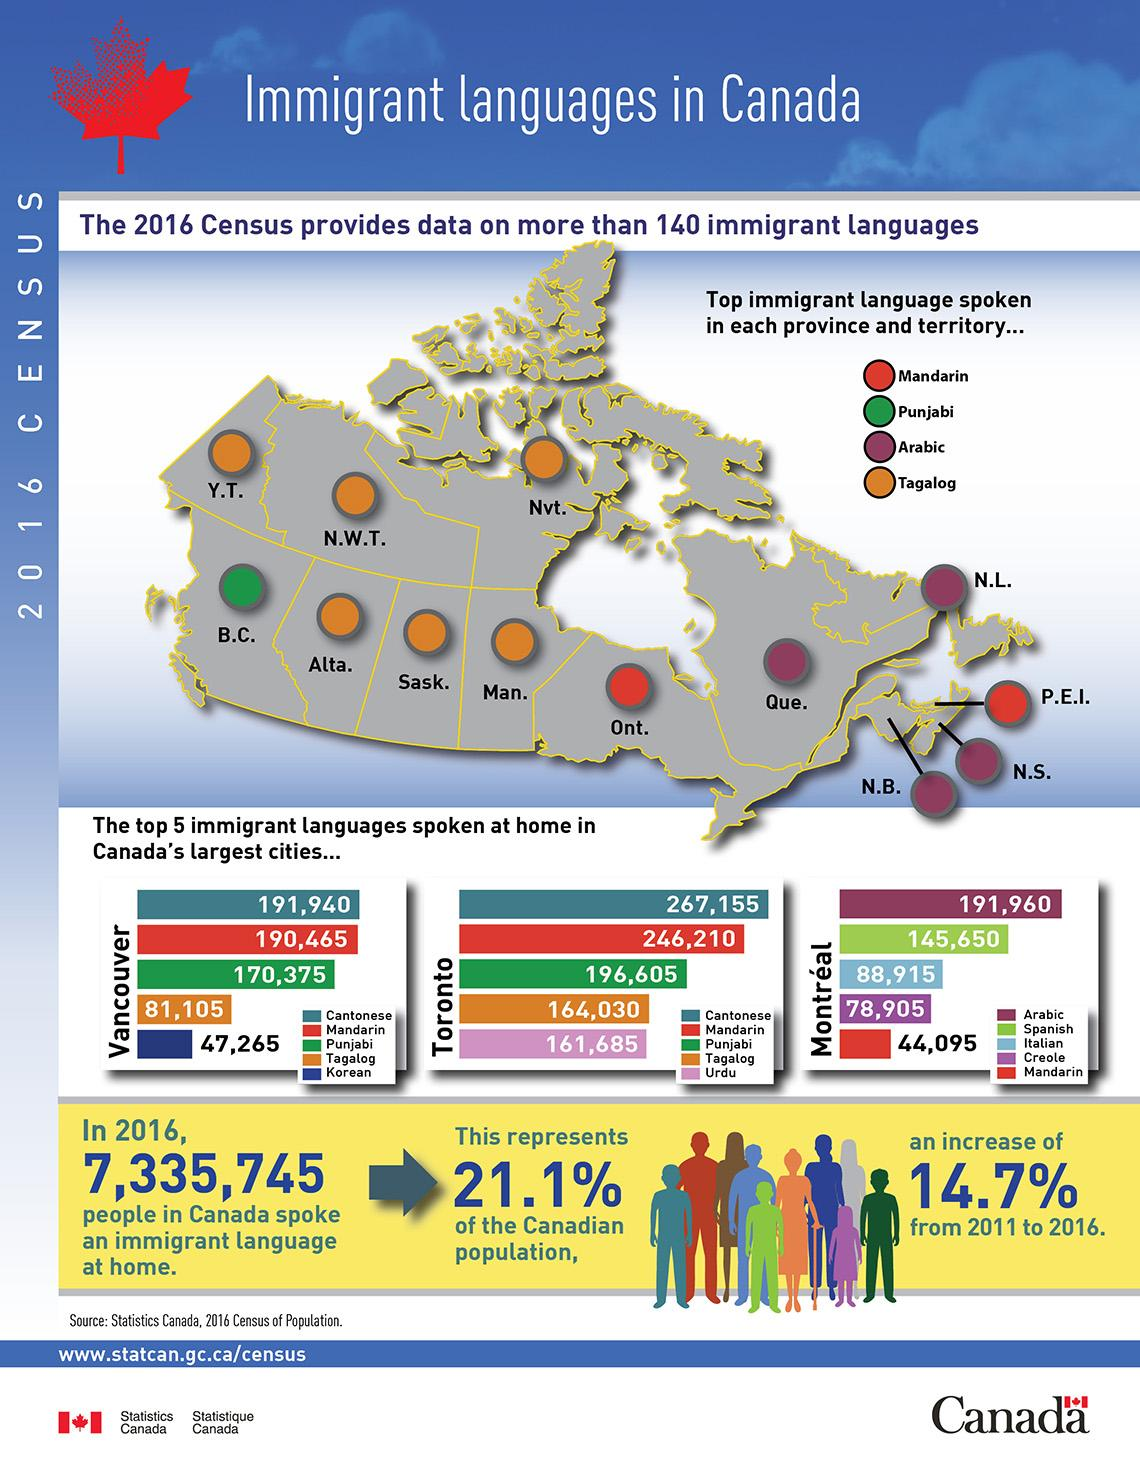Mention a couple of crucial points in this snapshot. The number of states where Mandarin is spoken by immigrants is two. Four states have Arabic as an immigrant language. There are six states in the United States where Tagalog is spoken by immigrants. There are 1 state in which Punjabi is an immigrant language. 